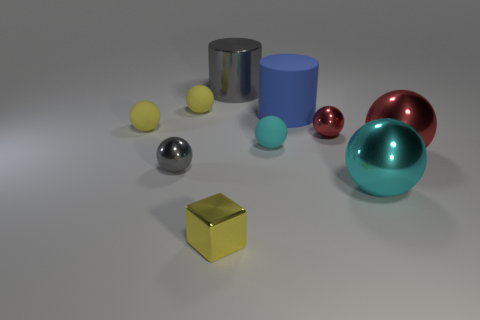Can you describe the overall arrangement and variety of shapes present in the image? Certainly! The image displays a collection of geometric shapes and objects neatly arranged with ample space between them. The assemblage includes spheres, cylinders, and a cube, featured in a range of sizes and colors. These objects rest on a flat surface and display various finishes—some exhibit a metallic sheen, while others have a matte texture. This composition highlights contrast, both in shape and color, creating an image that is simple yet visually engaging. 